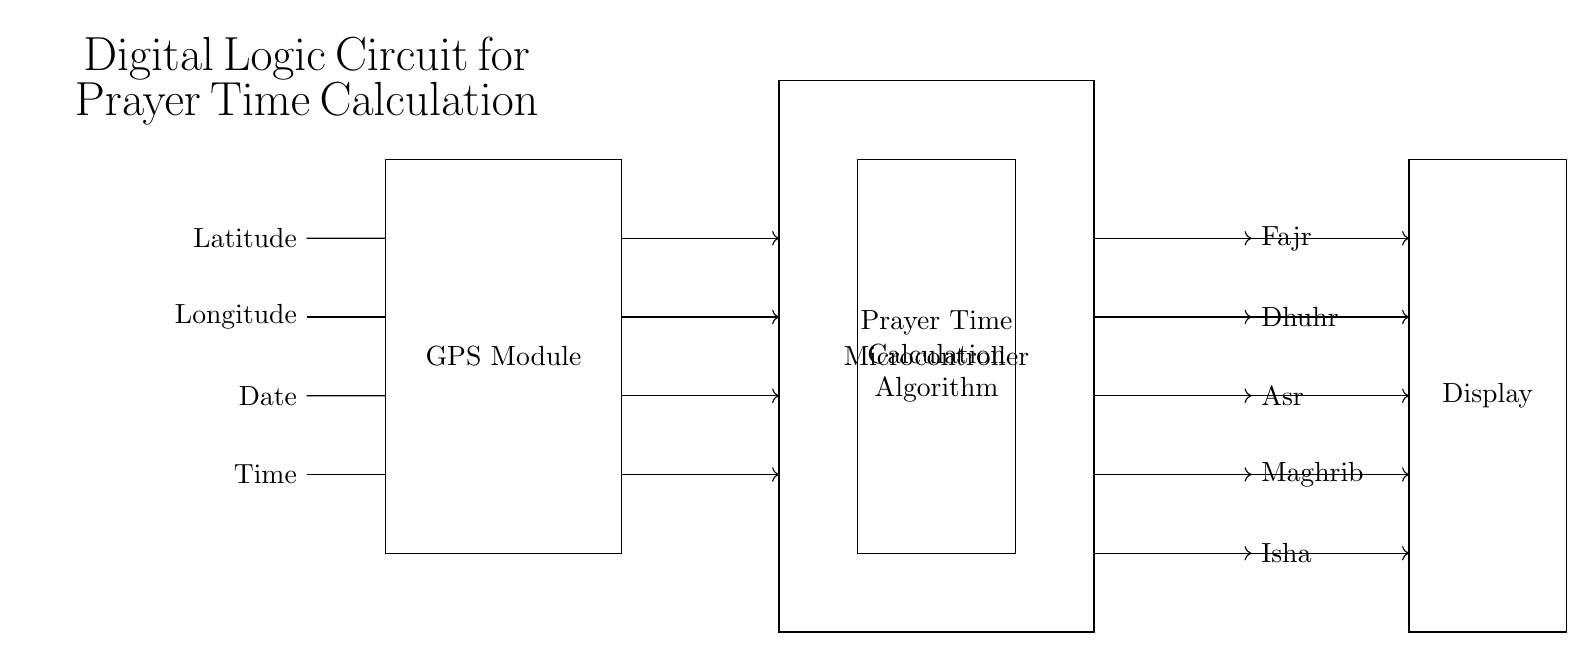What are the input signals of the circuit? The circuit receives Latitude, Longitude, Date, and Time as input signals, as indicated on the left side of the diagram.
Answer: Latitude, Longitude, Date, Time What component is responsible for calculating the prayer times? The microcontroller contains the prayer time calculation algorithm, which processes the input data and outputs the prayer times.
Answer: Microcontroller How many output prayer times does the circuit provide? The output section of the circuit indicates five distinct prayer times: Fajr, Dhuhr, Asr, Maghrib, and Isha.
Answer: Five What is the purpose of the GPS module in this circuit? The GPS module is used to obtain geographic information such as latitude and longitude, which are essential for calculating the precise prayer times based on location.
Answer: Obtain geographic information Explain the flow of information from inputs to outputs. Input signals (Latitude, Longitude, Date, Time) flow into the GPS module, which passes the essential data to the microcontroller. The microcontroller processes this data using the prayer time calculation algorithm and then sends the results to the output section for displaying the different prayer times.
Answer: Input to GPS to Microcontroller to Outputs What does the display component represent in this circuit? The display component shows the calculated prayer times (Fajr, Dhuhr, Asr, Maghrib, Isha) for the users, providing a visual representation of the output.
Answer: Shows prayer times 